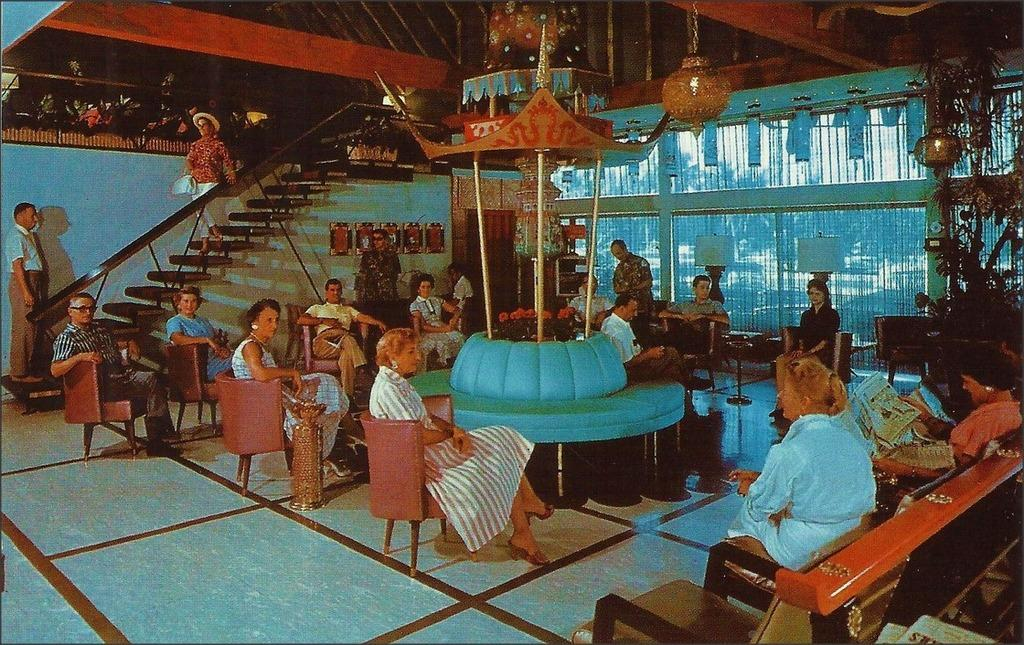Who or what can be seen in the image? There are people in the image. What are the people doing in the image? The people are sitting on chairs. In which direction are the people looking? The people are looking in a particular direction. What type of seed can be seen growing on the sea in the image? There is no seed or sea present in the image; it features people sitting on chairs and looking in a particular direction. 